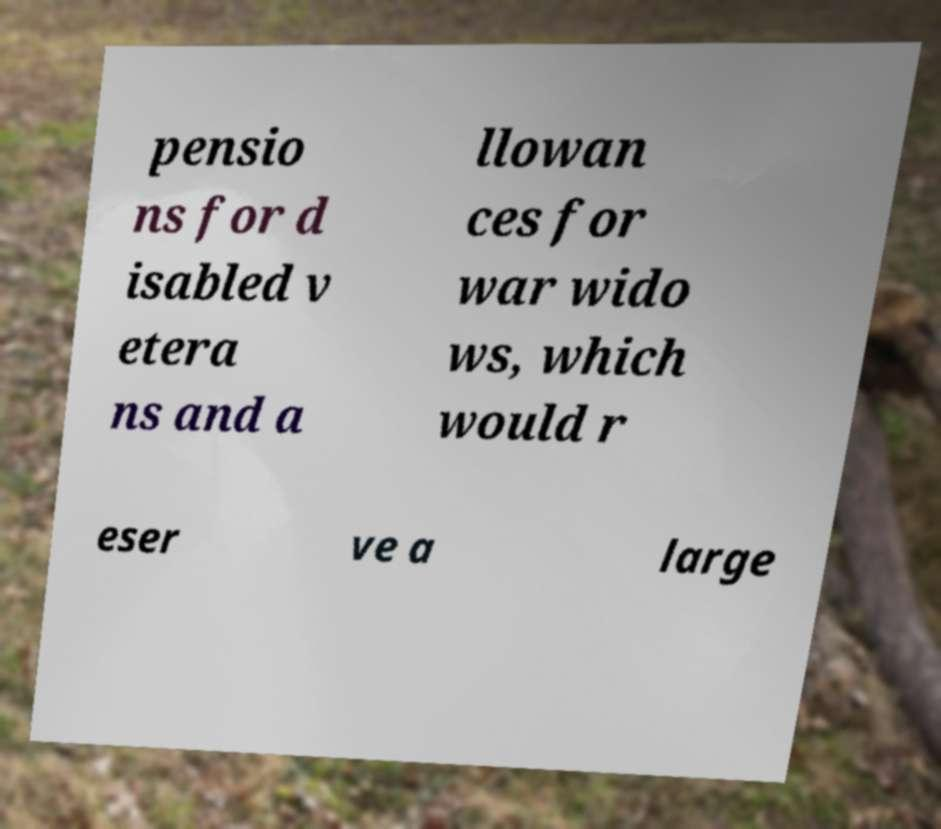Please read and relay the text visible in this image. What does it say? pensio ns for d isabled v etera ns and a llowan ces for war wido ws, which would r eser ve a large 